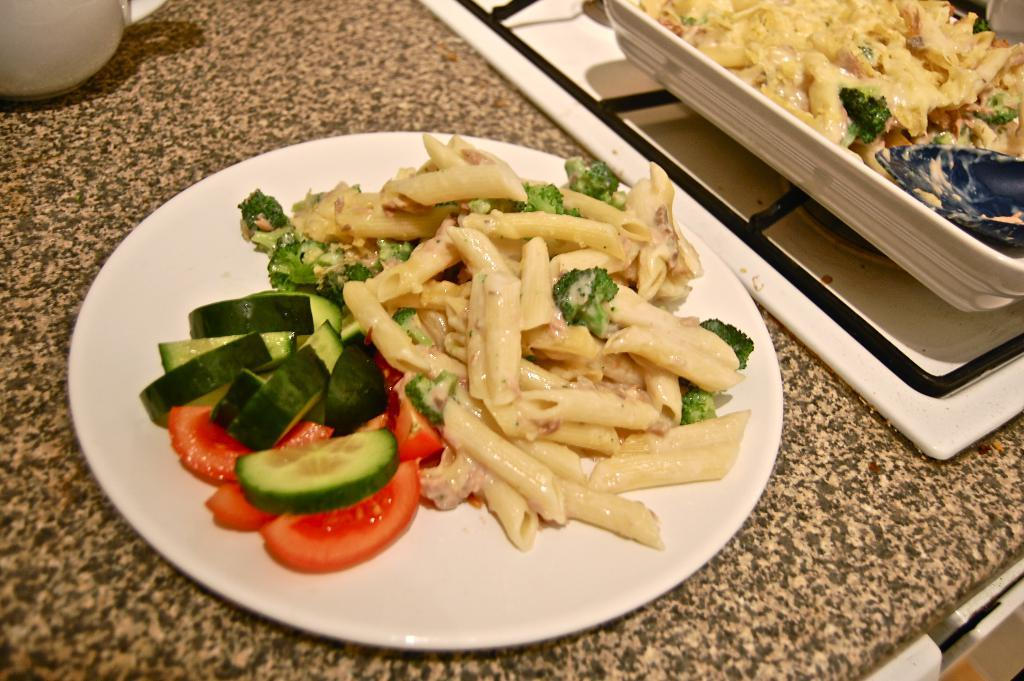What is the main dish featured in the center of the image? There is a plate with salad in the center of the image. Where is the plate with salad located? The plate is placed on a table. What other food item can be seen on the right side of the image? There is a bowl with food on the right side of the image. What type of beverage container is visible in the top left corner of the image? There is a cup in the top left corner of the image. What type of advertisement is being displayed on the plate with salad? There is no advertisement present on the plate with salad; it is a plate of salad. 